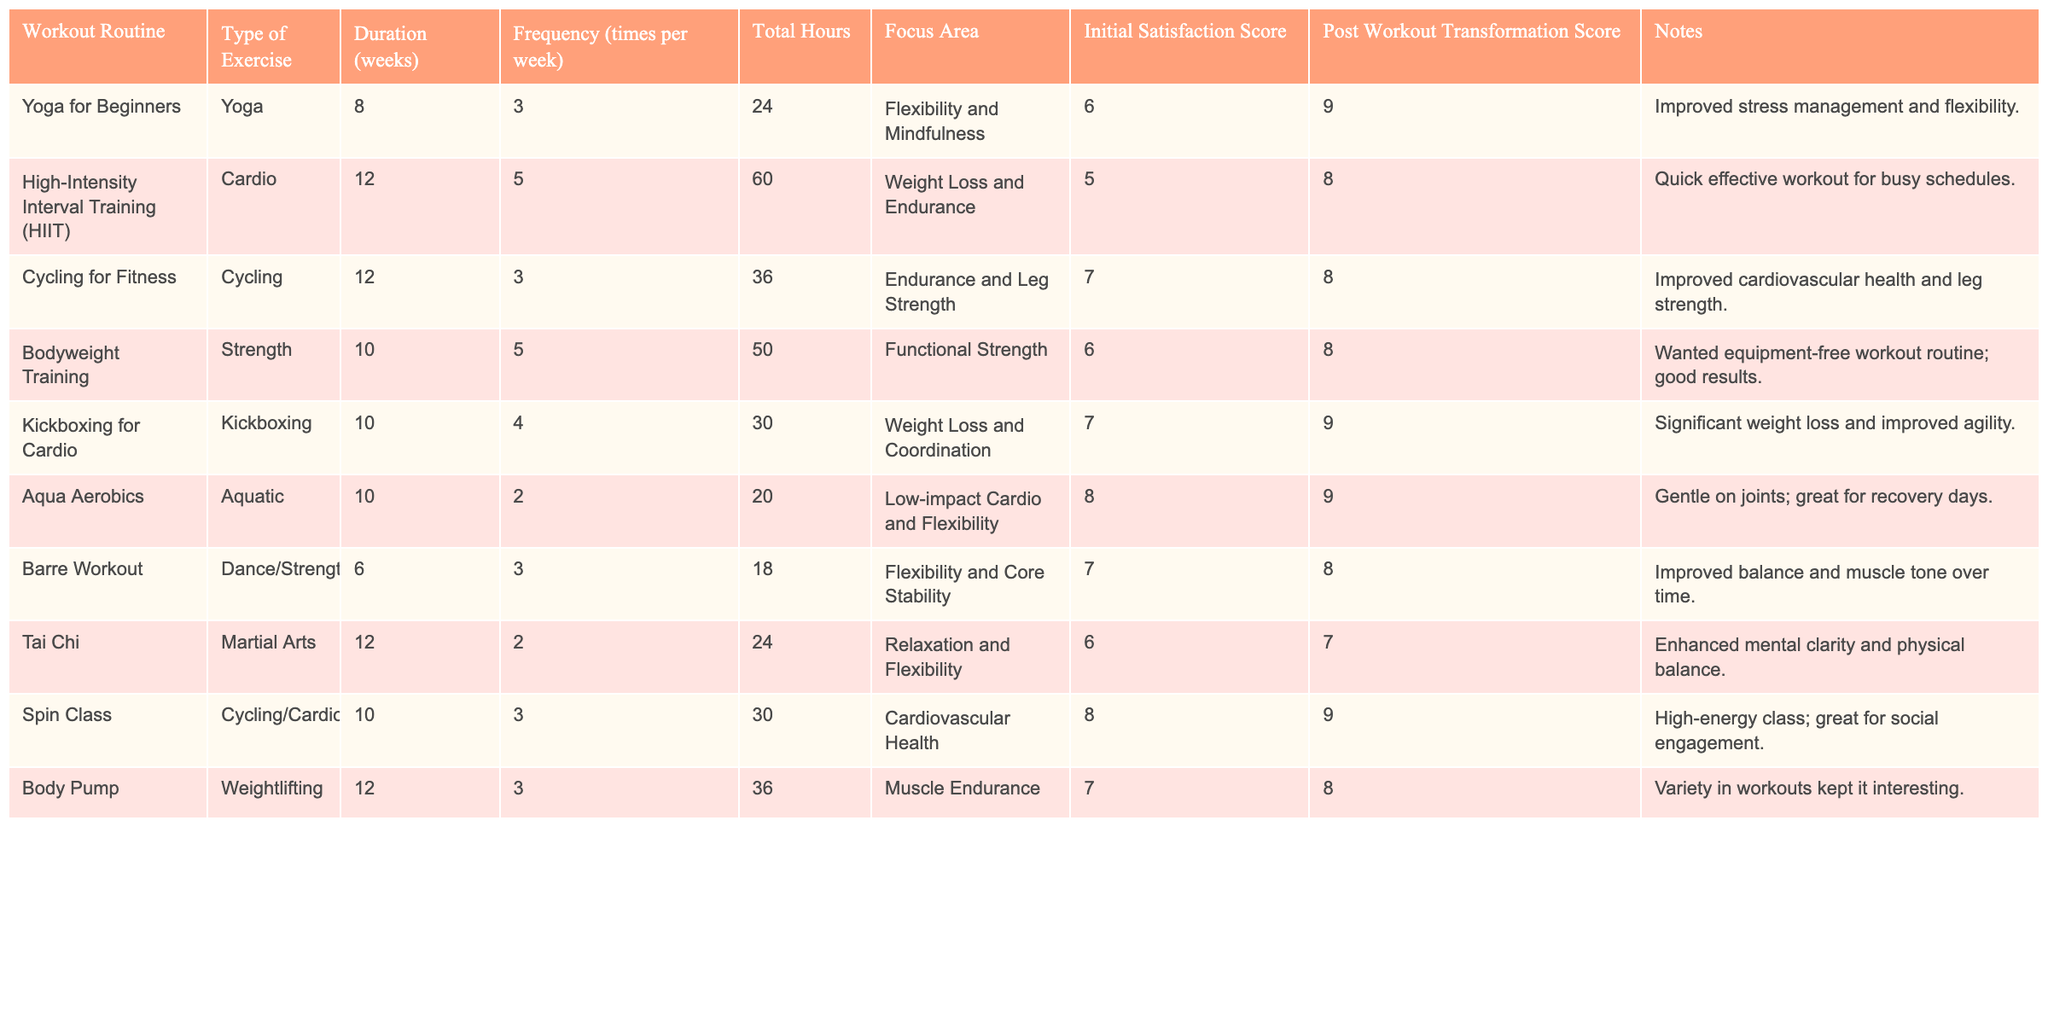What is the total workout duration for High-Intensity Interval Training? The workout duration for High-Intensity Interval Training is specified in the table as 12 weeks.
Answer: 12 weeks Which workout routine had the highest Initial Satisfaction Score? By scanning through the Initial Satisfaction Scores, Aqua Aerobics and Cycling for Fitness both have the highest score of 8. However, Aqua Aerobics had a higher Post Workout Transformation Score.
Answer: Aqua Aerobics What is the average frequency of workouts across all routines? To calculate the average frequency, we add the frequency values (3 + 5 + 3 + 5 + 4 + 2 + 3 + 2 + 3) = 30 and divide by the total number of routines (9), which gives us the average frequency of 30/9 = 3.33.
Answer: 3.33 times per week Did any workout routine focus solely on flexibility? According to the table, Yoga for Beginners and Tai Chi specifically highlight flexibility as their focus area. Thus, the answer is yes.
Answer: Yes What is the difference in the Post Workout Transformation Score between Bodyweight Training and Kickboxing for Cardio? The Post Workout Transformation Score for Bodyweight Training is 8, while for Kickboxing for Cardio, it is 9. The difference is 9 - 8 = 1.
Answer: 1 Which workout routines had both an Initial Satisfaction Score and a Post Workout Transformation Score of at least 8? Checking the table, Aqua Aerobics, Spin Class, and Kickboxing for Cardio all have scores of at least 8 in both categories.
Answer: Aqua Aerobics, Spin Class, Kickboxing for Cardio What is the total number of hours spent across all workout routines? The total hours can be calculated by summing the Total Hours column values (24 + 60 + 36 + 50 + 30 + 20 + 18 + 24 + 36) = 288.
Answer: 288 hours Which routine had a lower Initial Satisfaction Score, Kickboxing for Cardio or Body Pump? Kickboxing for Cardio has an Initial Satisfaction Score of 7, while Body Pump has a score of 7 as well. Since they are equal, neither routine had a lower score.
Answer: Neither Which workout routine has the longest duration and what is that duration? Looking through the table, both High-Intensity Interval Training and Cycling for Fitness have the longest duration of 12 weeks.
Answer: 12 weeks 